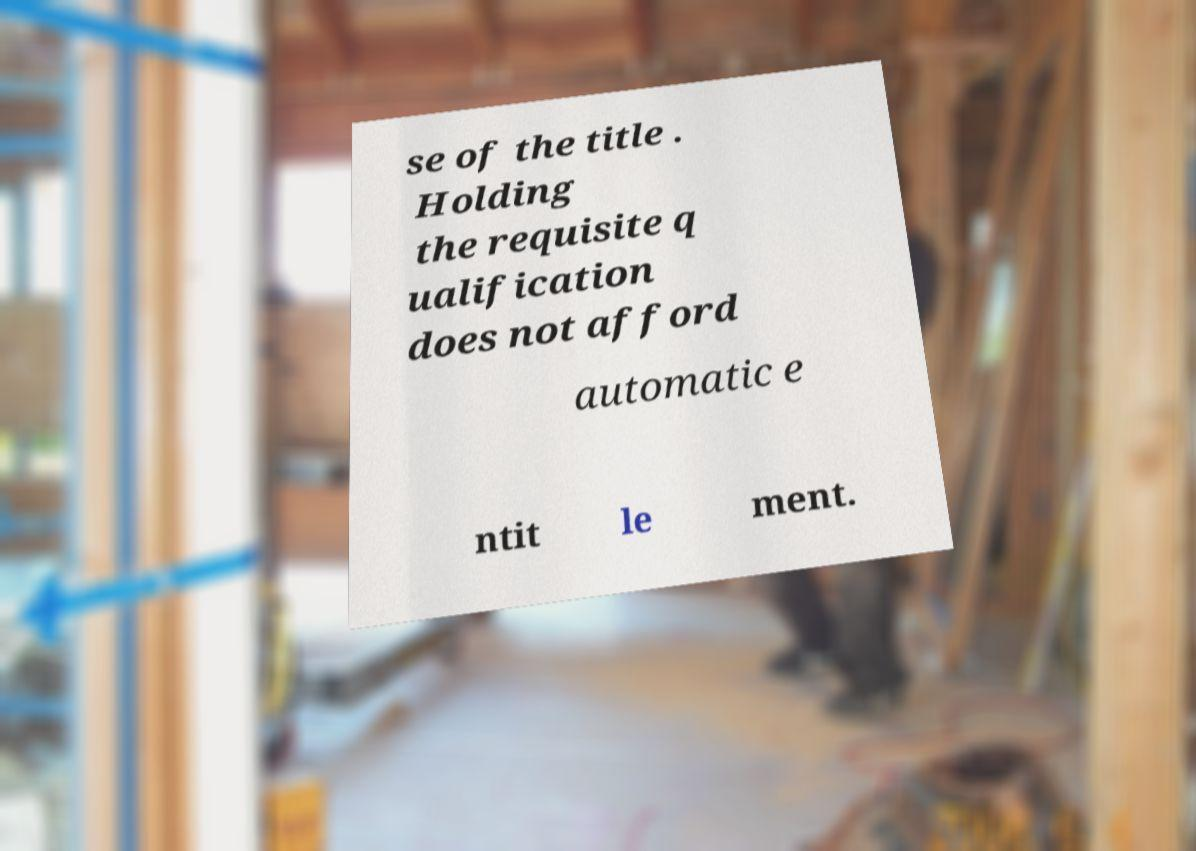For documentation purposes, I need the text within this image transcribed. Could you provide that? se of the title . Holding the requisite q ualification does not afford automatic e ntit le ment. 